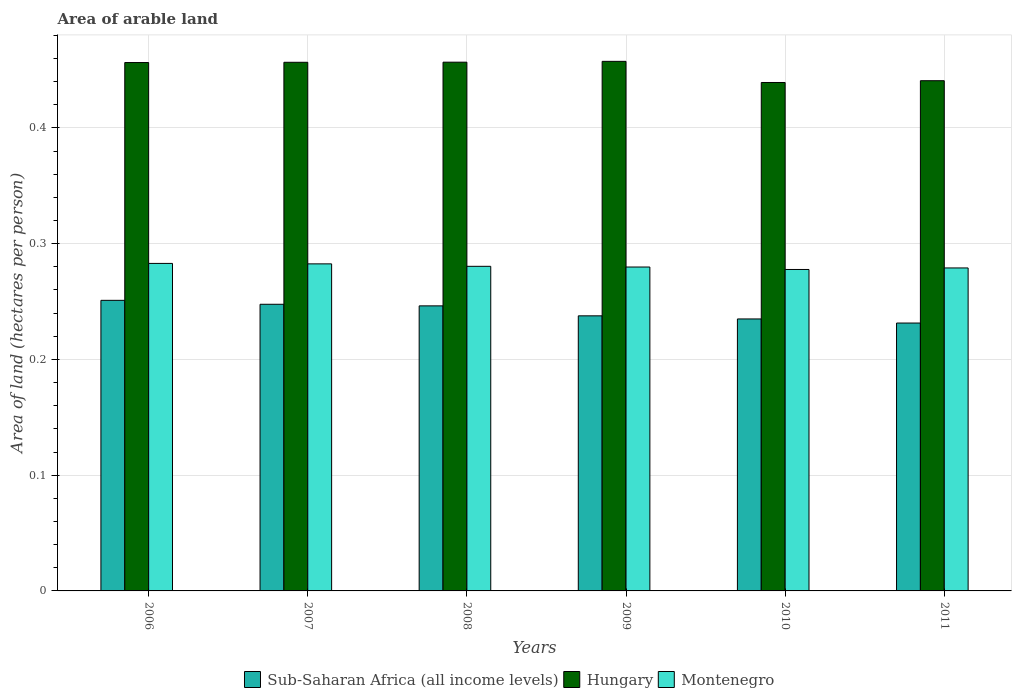Are the number of bars per tick equal to the number of legend labels?
Offer a very short reply. Yes. Are the number of bars on each tick of the X-axis equal?
Your answer should be very brief. Yes. What is the label of the 1st group of bars from the left?
Your answer should be very brief. 2006. In how many cases, is the number of bars for a given year not equal to the number of legend labels?
Provide a short and direct response. 0. What is the total arable land in Montenegro in 2011?
Give a very brief answer. 0.28. Across all years, what is the maximum total arable land in Montenegro?
Make the answer very short. 0.28. Across all years, what is the minimum total arable land in Montenegro?
Your answer should be very brief. 0.28. In which year was the total arable land in Sub-Saharan Africa (all income levels) minimum?
Give a very brief answer. 2011. What is the total total arable land in Montenegro in the graph?
Ensure brevity in your answer.  1.68. What is the difference between the total arable land in Montenegro in 2009 and that in 2010?
Provide a succinct answer. 0. What is the difference between the total arable land in Sub-Saharan Africa (all income levels) in 2007 and the total arable land in Hungary in 2010?
Make the answer very short. -0.19. What is the average total arable land in Sub-Saharan Africa (all income levels) per year?
Provide a short and direct response. 0.24. In the year 2010, what is the difference between the total arable land in Sub-Saharan Africa (all income levels) and total arable land in Montenegro?
Ensure brevity in your answer.  -0.04. In how many years, is the total arable land in Sub-Saharan Africa (all income levels) greater than 0.24000000000000002 hectares per person?
Ensure brevity in your answer.  3. What is the ratio of the total arable land in Sub-Saharan Africa (all income levels) in 2007 to that in 2011?
Keep it short and to the point. 1.07. Is the total arable land in Sub-Saharan Africa (all income levels) in 2009 less than that in 2010?
Give a very brief answer. No. What is the difference between the highest and the second highest total arable land in Sub-Saharan Africa (all income levels)?
Provide a short and direct response. 0. What is the difference between the highest and the lowest total arable land in Sub-Saharan Africa (all income levels)?
Your answer should be very brief. 0.02. What does the 2nd bar from the left in 2009 represents?
Make the answer very short. Hungary. What does the 3rd bar from the right in 2008 represents?
Your answer should be compact. Sub-Saharan Africa (all income levels). Are all the bars in the graph horizontal?
Provide a succinct answer. No. How many years are there in the graph?
Offer a terse response. 6. Are the values on the major ticks of Y-axis written in scientific E-notation?
Provide a succinct answer. No. Where does the legend appear in the graph?
Provide a succinct answer. Bottom center. How many legend labels are there?
Provide a succinct answer. 3. What is the title of the graph?
Your answer should be very brief. Area of arable land. Does "Liberia" appear as one of the legend labels in the graph?
Offer a very short reply. No. What is the label or title of the X-axis?
Make the answer very short. Years. What is the label or title of the Y-axis?
Ensure brevity in your answer.  Area of land (hectares per person). What is the Area of land (hectares per person) in Sub-Saharan Africa (all income levels) in 2006?
Offer a terse response. 0.25. What is the Area of land (hectares per person) of Hungary in 2006?
Offer a terse response. 0.46. What is the Area of land (hectares per person) in Montenegro in 2006?
Your answer should be compact. 0.28. What is the Area of land (hectares per person) of Sub-Saharan Africa (all income levels) in 2007?
Offer a very short reply. 0.25. What is the Area of land (hectares per person) in Hungary in 2007?
Your answer should be very brief. 0.46. What is the Area of land (hectares per person) in Montenegro in 2007?
Offer a very short reply. 0.28. What is the Area of land (hectares per person) of Sub-Saharan Africa (all income levels) in 2008?
Give a very brief answer. 0.25. What is the Area of land (hectares per person) of Hungary in 2008?
Make the answer very short. 0.46. What is the Area of land (hectares per person) in Montenegro in 2008?
Offer a terse response. 0.28. What is the Area of land (hectares per person) of Sub-Saharan Africa (all income levels) in 2009?
Your response must be concise. 0.24. What is the Area of land (hectares per person) of Hungary in 2009?
Your response must be concise. 0.46. What is the Area of land (hectares per person) in Montenegro in 2009?
Give a very brief answer. 0.28. What is the Area of land (hectares per person) of Sub-Saharan Africa (all income levels) in 2010?
Ensure brevity in your answer.  0.23. What is the Area of land (hectares per person) of Hungary in 2010?
Give a very brief answer. 0.44. What is the Area of land (hectares per person) in Montenegro in 2010?
Provide a succinct answer. 0.28. What is the Area of land (hectares per person) in Sub-Saharan Africa (all income levels) in 2011?
Provide a succinct answer. 0.23. What is the Area of land (hectares per person) of Hungary in 2011?
Make the answer very short. 0.44. What is the Area of land (hectares per person) of Montenegro in 2011?
Provide a short and direct response. 0.28. Across all years, what is the maximum Area of land (hectares per person) of Sub-Saharan Africa (all income levels)?
Make the answer very short. 0.25. Across all years, what is the maximum Area of land (hectares per person) of Hungary?
Keep it short and to the point. 0.46. Across all years, what is the maximum Area of land (hectares per person) in Montenegro?
Ensure brevity in your answer.  0.28. Across all years, what is the minimum Area of land (hectares per person) of Sub-Saharan Africa (all income levels)?
Offer a very short reply. 0.23. Across all years, what is the minimum Area of land (hectares per person) in Hungary?
Give a very brief answer. 0.44. Across all years, what is the minimum Area of land (hectares per person) in Montenegro?
Make the answer very short. 0.28. What is the total Area of land (hectares per person) in Sub-Saharan Africa (all income levels) in the graph?
Make the answer very short. 1.45. What is the total Area of land (hectares per person) in Hungary in the graph?
Make the answer very short. 2.71. What is the total Area of land (hectares per person) in Montenegro in the graph?
Provide a short and direct response. 1.68. What is the difference between the Area of land (hectares per person) in Sub-Saharan Africa (all income levels) in 2006 and that in 2007?
Provide a short and direct response. 0. What is the difference between the Area of land (hectares per person) of Hungary in 2006 and that in 2007?
Your answer should be compact. -0. What is the difference between the Area of land (hectares per person) of Montenegro in 2006 and that in 2007?
Provide a succinct answer. 0. What is the difference between the Area of land (hectares per person) in Sub-Saharan Africa (all income levels) in 2006 and that in 2008?
Provide a short and direct response. 0. What is the difference between the Area of land (hectares per person) in Hungary in 2006 and that in 2008?
Offer a terse response. -0. What is the difference between the Area of land (hectares per person) of Montenegro in 2006 and that in 2008?
Provide a succinct answer. 0. What is the difference between the Area of land (hectares per person) of Sub-Saharan Africa (all income levels) in 2006 and that in 2009?
Make the answer very short. 0.01. What is the difference between the Area of land (hectares per person) in Hungary in 2006 and that in 2009?
Keep it short and to the point. -0. What is the difference between the Area of land (hectares per person) of Montenegro in 2006 and that in 2009?
Ensure brevity in your answer.  0. What is the difference between the Area of land (hectares per person) of Sub-Saharan Africa (all income levels) in 2006 and that in 2010?
Keep it short and to the point. 0.02. What is the difference between the Area of land (hectares per person) in Hungary in 2006 and that in 2010?
Ensure brevity in your answer.  0.02. What is the difference between the Area of land (hectares per person) in Montenegro in 2006 and that in 2010?
Offer a very short reply. 0.01. What is the difference between the Area of land (hectares per person) in Sub-Saharan Africa (all income levels) in 2006 and that in 2011?
Make the answer very short. 0.02. What is the difference between the Area of land (hectares per person) of Hungary in 2006 and that in 2011?
Offer a very short reply. 0.02. What is the difference between the Area of land (hectares per person) in Montenegro in 2006 and that in 2011?
Offer a very short reply. 0. What is the difference between the Area of land (hectares per person) of Sub-Saharan Africa (all income levels) in 2007 and that in 2008?
Ensure brevity in your answer.  0. What is the difference between the Area of land (hectares per person) in Hungary in 2007 and that in 2008?
Offer a terse response. -0. What is the difference between the Area of land (hectares per person) of Montenegro in 2007 and that in 2008?
Your response must be concise. 0. What is the difference between the Area of land (hectares per person) in Hungary in 2007 and that in 2009?
Offer a terse response. -0. What is the difference between the Area of land (hectares per person) of Montenegro in 2007 and that in 2009?
Your answer should be very brief. 0. What is the difference between the Area of land (hectares per person) of Sub-Saharan Africa (all income levels) in 2007 and that in 2010?
Your answer should be compact. 0.01. What is the difference between the Area of land (hectares per person) in Hungary in 2007 and that in 2010?
Ensure brevity in your answer.  0.02. What is the difference between the Area of land (hectares per person) of Montenegro in 2007 and that in 2010?
Offer a terse response. 0. What is the difference between the Area of land (hectares per person) of Sub-Saharan Africa (all income levels) in 2007 and that in 2011?
Ensure brevity in your answer.  0.02. What is the difference between the Area of land (hectares per person) of Hungary in 2007 and that in 2011?
Offer a terse response. 0.02. What is the difference between the Area of land (hectares per person) in Montenegro in 2007 and that in 2011?
Give a very brief answer. 0. What is the difference between the Area of land (hectares per person) of Sub-Saharan Africa (all income levels) in 2008 and that in 2009?
Provide a short and direct response. 0.01. What is the difference between the Area of land (hectares per person) of Hungary in 2008 and that in 2009?
Provide a succinct answer. -0. What is the difference between the Area of land (hectares per person) in Montenegro in 2008 and that in 2009?
Ensure brevity in your answer.  0. What is the difference between the Area of land (hectares per person) of Sub-Saharan Africa (all income levels) in 2008 and that in 2010?
Make the answer very short. 0.01. What is the difference between the Area of land (hectares per person) of Hungary in 2008 and that in 2010?
Make the answer very short. 0.02. What is the difference between the Area of land (hectares per person) of Montenegro in 2008 and that in 2010?
Your answer should be compact. 0. What is the difference between the Area of land (hectares per person) of Sub-Saharan Africa (all income levels) in 2008 and that in 2011?
Your answer should be compact. 0.01. What is the difference between the Area of land (hectares per person) of Hungary in 2008 and that in 2011?
Ensure brevity in your answer.  0.02. What is the difference between the Area of land (hectares per person) in Montenegro in 2008 and that in 2011?
Provide a succinct answer. 0. What is the difference between the Area of land (hectares per person) of Sub-Saharan Africa (all income levels) in 2009 and that in 2010?
Give a very brief answer. 0. What is the difference between the Area of land (hectares per person) of Hungary in 2009 and that in 2010?
Your response must be concise. 0.02. What is the difference between the Area of land (hectares per person) in Montenegro in 2009 and that in 2010?
Offer a terse response. 0. What is the difference between the Area of land (hectares per person) in Sub-Saharan Africa (all income levels) in 2009 and that in 2011?
Make the answer very short. 0.01. What is the difference between the Area of land (hectares per person) of Hungary in 2009 and that in 2011?
Your response must be concise. 0.02. What is the difference between the Area of land (hectares per person) in Montenegro in 2009 and that in 2011?
Your answer should be very brief. 0. What is the difference between the Area of land (hectares per person) of Sub-Saharan Africa (all income levels) in 2010 and that in 2011?
Keep it short and to the point. 0. What is the difference between the Area of land (hectares per person) in Hungary in 2010 and that in 2011?
Your answer should be very brief. -0. What is the difference between the Area of land (hectares per person) in Montenegro in 2010 and that in 2011?
Give a very brief answer. -0. What is the difference between the Area of land (hectares per person) of Sub-Saharan Africa (all income levels) in 2006 and the Area of land (hectares per person) of Hungary in 2007?
Offer a terse response. -0.21. What is the difference between the Area of land (hectares per person) of Sub-Saharan Africa (all income levels) in 2006 and the Area of land (hectares per person) of Montenegro in 2007?
Ensure brevity in your answer.  -0.03. What is the difference between the Area of land (hectares per person) in Hungary in 2006 and the Area of land (hectares per person) in Montenegro in 2007?
Ensure brevity in your answer.  0.17. What is the difference between the Area of land (hectares per person) in Sub-Saharan Africa (all income levels) in 2006 and the Area of land (hectares per person) in Hungary in 2008?
Offer a very short reply. -0.21. What is the difference between the Area of land (hectares per person) of Sub-Saharan Africa (all income levels) in 2006 and the Area of land (hectares per person) of Montenegro in 2008?
Offer a terse response. -0.03. What is the difference between the Area of land (hectares per person) of Hungary in 2006 and the Area of land (hectares per person) of Montenegro in 2008?
Your response must be concise. 0.18. What is the difference between the Area of land (hectares per person) in Sub-Saharan Africa (all income levels) in 2006 and the Area of land (hectares per person) in Hungary in 2009?
Your response must be concise. -0.21. What is the difference between the Area of land (hectares per person) of Sub-Saharan Africa (all income levels) in 2006 and the Area of land (hectares per person) of Montenegro in 2009?
Provide a short and direct response. -0.03. What is the difference between the Area of land (hectares per person) of Hungary in 2006 and the Area of land (hectares per person) of Montenegro in 2009?
Ensure brevity in your answer.  0.18. What is the difference between the Area of land (hectares per person) of Sub-Saharan Africa (all income levels) in 2006 and the Area of land (hectares per person) of Hungary in 2010?
Provide a short and direct response. -0.19. What is the difference between the Area of land (hectares per person) of Sub-Saharan Africa (all income levels) in 2006 and the Area of land (hectares per person) of Montenegro in 2010?
Your answer should be compact. -0.03. What is the difference between the Area of land (hectares per person) in Hungary in 2006 and the Area of land (hectares per person) in Montenegro in 2010?
Your answer should be very brief. 0.18. What is the difference between the Area of land (hectares per person) in Sub-Saharan Africa (all income levels) in 2006 and the Area of land (hectares per person) in Hungary in 2011?
Your answer should be compact. -0.19. What is the difference between the Area of land (hectares per person) in Sub-Saharan Africa (all income levels) in 2006 and the Area of land (hectares per person) in Montenegro in 2011?
Your answer should be very brief. -0.03. What is the difference between the Area of land (hectares per person) of Hungary in 2006 and the Area of land (hectares per person) of Montenegro in 2011?
Your answer should be very brief. 0.18. What is the difference between the Area of land (hectares per person) in Sub-Saharan Africa (all income levels) in 2007 and the Area of land (hectares per person) in Hungary in 2008?
Ensure brevity in your answer.  -0.21. What is the difference between the Area of land (hectares per person) in Sub-Saharan Africa (all income levels) in 2007 and the Area of land (hectares per person) in Montenegro in 2008?
Provide a short and direct response. -0.03. What is the difference between the Area of land (hectares per person) of Hungary in 2007 and the Area of land (hectares per person) of Montenegro in 2008?
Offer a terse response. 0.18. What is the difference between the Area of land (hectares per person) in Sub-Saharan Africa (all income levels) in 2007 and the Area of land (hectares per person) in Hungary in 2009?
Offer a very short reply. -0.21. What is the difference between the Area of land (hectares per person) of Sub-Saharan Africa (all income levels) in 2007 and the Area of land (hectares per person) of Montenegro in 2009?
Your answer should be compact. -0.03. What is the difference between the Area of land (hectares per person) of Hungary in 2007 and the Area of land (hectares per person) of Montenegro in 2009?
Provide a short and direct response. 0.18. What is the difference between the Area of land (hectares per person) of Sub-Saharan Africa (all income levels) in 2007 and the Area of land (hectares per person) of Hungary in 2010?
Provide a short and direct response. -0.19. What is the difference between the Area of land (hectares per person) of Sub-Saharan Africa (all income levels) in 2007 and the Area of land (hectares per person) of Montenegro in 2010?
Your answer should be very brief. -0.03. What is the difference between the Area of land (hectares per person) in Hungary in 2007 and the Area of land (hectares per person) in Montenegro in 2010?
Provide a succinct answer. 0.18. What is the difference between the Area of land (hectares per person) in Sub-Saharan Africa (all income levels) in 2007 and the Area of land (hectares per person) in Hungary in 2011?
Provide a succinct answer. -0.19. What is the difference between the Area of land (hectares per person) of Sub-Saharan Africa (all income levels) in 2007 and the Area of land (hectares per person) of Montenegro in 2011?
Ensure brevity in your answer.  -0.03. What is the difference between the Area of land (hectares per person) in Hungary in 2007 and the Area of land (hectares per person) in Montenegro in 2011?
Offer a terse response. 0.18. What is the difference between the Area of land (hectares per person) of Sub-Saharan Africa (all income levels) in 2008 and the Area of land (hectares per person) of Hungary in 2009?
Keep it short and to the point. -0.21. What is the difference between the Area of land (hectares per person) of Sub-Saharan Africa (all income levels) in 2008 and the Area of land (hectares per person) of Montenegro in 2009?
Your answer should be very brief. -0.03. What is the difference between the Area of land (hectares per person) of Hungary in 2008 and the Area of land (hectares per person) of Montenegro in 2009?
Your response must be concise. 0.18. What is the difference between the Area of land (hectares per person) in Sub-Saharan Africa (all income levels) in 2008 and the Area of land (hectares per person) in Hungary in 2010?
Provide a succinct answer. -0.19. What is the difference between the Area of land (hectares per person) of Sub-Saharan Africa (all income levels) in 2008 and the Area of land (hectares per person) of Montenegro in 2010?
Offer a very short reply. -0.03. What is the difference between the Area of land (hectares per person) of Hungary in 2008 and the Area of land (hectares per person) of Montenegro in 2010?
Give a very brief answer. 0.18. What is the difference between the Area of land (hectares per person) of Sub-Saharan Africa (all income levels) in 2008 and the Area of land (hectares per person) of Hungary in 2011?
Make the answer very short. -0.19. What is the difference between the Area of land (hectares per person) of Sub-Saharan Africa (all income levels) in 2008 and the Area of land (hectares per person) of Montenegro in 2011?
Your answer should be very brief. -0.03. What is the difference between the Area of land (hectares per person) of Hungary in 2008 and the Area of land (hectares per person) of Montenegro in 2011?
Provide a succinct answer. 0.18. What is the difference between the Area of land (hectares per person) in Sub-Saharan Africa (all income levels) in 2009 and the Area of land (hectares per person) in Hungary in 2010?
Ensure brevity in your answer.  -0.2. What is the difference between the Area of land (hectares per person) of Sub-Saharan Africa (all income levels) in 2009 and the Area of land (hectares per person) of Montenegro in 2010?
Ensure brevity in your answer.  -0.04. What is the difference between the Area of land (hectares per person) of Hungary in 2009 and the Area of land (hectares per person) of Montenegro in 2010?
Ensure brevity in your answer.  0.18. What is the difference between the Area of land (hectares per person) in Sub-Saharan Africa (all income levels) in 2009 and the Area of land (hectares per person) in Hungary in 2011?
Your response must be concise. -0.2. What is the difference between the Area of land (hectares per person) in Sub-Saharan Africa (all income levels) in 2009 and the Area of land (hectares per person) in Montenegro in 2011?
Ensure brevity in your answer.  -0.04. What is the difference between the Area of land (hectares per person) in Hungary in 2009 and the Area of land (hectares per person) in Montenegro in 2011?
Your response must be concise. 0.18. What is the difference between the Area of land (hectares per person) in Sub-Saharan Africa (all income levels) in 2010 and the Area of land (hectares per person) in Hungary in 2011?
Provide a short and direct response. -0.21. What is the difference between the Area of land (hectares per person) in Sub-Saharan Africa (all income levels) in 2010 and the Area of land (hectares per person) in Montenegro in 2011?
Your response must be concise. -0.04. What is the difference between the Area of land (hectares per person) of Hungary in 2010 and the Area of land (hectares per person) of Montenegro in 2011?
Provide a succinct answer. 0.16. What is the average Area of land (hectares per person) of Sub-Saharan Africa (all income levels) per year?
Offer a very short reply. 0.24. What is the average Area of land (hectares per person) of Hungary per year?
Provide a succinct answer. 0.45. What is the average Area of land (hectares per person) in Montenegro per year?
Ensure brevity in your answer.  0.28. In the year 2006, what is the difference between the Area of land (hectares per person) in Sub-Saharan Africa (all income levels) and Area of land (hectares per person) in Hungary?
Your answer should be very brief. -0.21. In the year 2006, what is the difference between the Area of land (hectares per person) of Sub-Saharan Africa (all income levels) and Area of land (hectares per person) of Montenegro?
Offer a very short reply. -0.03. In the year 2006, what is the difference between the Area of land (hectares per person) of Hungary and Area of land (hectares per person) of Montenegro?
Give a very brief answer. 0.17. In the year 2007, what is the difference between the Area of land (hectares per person) of Sub-Saharan Africa (all income levels) and Area of land (hectares per person) of Hungary?
Your answer should be very brief. -0.21. In the year 2007, what is the difference between the Area of land (hectares per person) of Sub-Saharan Africa (all income levels) and Area of land (hectares per person) of Montenegro?
Keep it short and to the point. -0.03. In the year 2007, what is the difference between the Area of land (hectares per person) in Hungary and Area of land (hectares per person) in Montenegro?
Ensure brevity in your answer.  0.17. In the year 2008, what is the difference between the Area of land (hectares per person) of Sub-Saharan Africa (all income levels) and Area of land (hectares per person) of Hungary?
Provide a succinct answer. -0.21. In the year 2008, what is the difference between the Area of land (hectares per person) of Sub-Saharan Africa (all income levels) and Area of land (hectares per person) of Montenegro?
Provide a short and direct response. -0.03. In the year 2008, what is the difference between the Area of land (hectares per person) of Hungary and Area of land (hectares per person) of Montenegro?
Your response must be concise. 0.18. In the year 2009, what is the difference between the Area of land (hectares per person) in Sub-Saharan Africa (all income levels) and Area of land (hectares per person) in Hungary?
Provide a short and direct response. -0.22. In the year 2009, what is the difference between the Area of land (hectares per person) of Sub-Saharan Africa (all income levels) and Area of land (hectares per person) of Montenegro?
Ensure brevity in your answer.  -0.04. In the year 2009, what is the difference between the Area of land (hectares per person) of Hungary and Area of land (hectares per person) of Montenegro?
Your response must be concise. 0.18. In the year 2010, what is the difference between the Area of land (hectares per person) of Sub-Saharan Africa (all income levels) and Area of land (hectares per person) of Hungary?
Your answer should be very brief. -0.2. In the year 2010, what is the difference between the Area of land (hectares per person) in Sub-Saharan Africa (all income levels) and Area of land (hectares per person) in Montenegro?
Offer a very short reply. -0.04. In the year 2010, what is the difference between the Area of land (hectares per person) of Hungary and Area of land (hectares per person) of Montenegro?
Your answer should be compact. 0.16. In the year 2011, what is the difference between the Area of land (hectares per person) in Sub-Saharan Africa (all income levels) and Area of land (hectares per person) in Hungary?
Provide a short and direct response. -0.21. In the year 2011, what is the difference between the Area of land (hectares per person) in Sub-Saharan Africa (all income levels) and Area of land (hectares per person) in Montenegro?
Provide a succinct answer. -0.05. In the year 2011, what is the difference between the Area of land (hectares per person) of Hungary and Area of land (hectares per person) of Montenegro?
Provide a succinct answer. 0.16. What is the ratio of the Area of land (hectares per person) of Sub-Saharan Africa (all income levels) in 2006 to that in 2007?
Offer a very short reply. 1.01. What is the ratio of the Area of land (hectares per person) of Hungary in 2006 to that in 2007?
Provide a succinct answer. 1. What is the ratio of the Area of land (hectares per person) in Sub-Saharan Africa (all income levels) in 2006 to that in 2008?
Offer a very short reply. 1.02. What is the ratio of the Area of land (hectares per person) of Hungary in 2006 to that in 2008?
Your answer should be compact. 1. What is the ratio of the Area of land (hectares per person) of Sub-Saharan Africa (all income levels) in 2006 to that in 2009?
Provide a short and direct response. 1.06. What is the ratio of the Area of land (hectares per person) of Hungary in 2006 to that in 2009?
Your answer should be compact. 1. What is the ratio of the Area of land (hectares per person) of Montenegro in 2006 to that in 2009?
Give a very brief answer. 1.01. What is the ratio of the Area of land (hectares per person) in Sub-Saharan Africa (all income levels) in 2006 to that in 2010?
Your answer should be very brief. 1.07. What is the ratio of the Area of land (hectares per person) of Hungary in 2006 to that in 2010?
Offer a very short reply. 1.04. What is the ratio of the Area of land (hectares per person) in Montenegro in 2006 to that in 2010?
Offer a very short reply. 1.02. What is the ratio of the Area of land (hectares per person) in Sub-Saharan Africa (all income levels) in 2006 to that in 2011?
Make the answer very short. 1.08. What is the ratio of the Area of land (hectares per person) in Hungary in 2006 to that in 2011?
Keep it short and to the point. 1.04. What is the ratio of the Area of land (hectares per person) in Montenegro in 2006 to that in 2011?
Offer a terse response. 1.01. What is the ratio of the Area of land (hectares per person) in Sub-Saharan Africa (all income levels) in 2007 to that in 2008?
Provide a succinct answer. 1.01. What is the ratio of the Area of land (hectares per person) of Hungary in 2007 to that in 2008?
Give a very brief answer. 1. What is the ratio of the Area of land (hectares per person) in Montenegro in 2007 to that in 2008?
Your answer should be very brief. 1.01. What is the ratio of the Area of land (hectares per person) in Sub-Saharan Africa (all income levels) in 2007 to that in 2009?
Offer a very short reply. 1.04. What is the ratio of the Area of land (hectares per person) in Montenegro in 2007 to that in 2009?
Offer a terse response. 1.01. What is the ratio of the Area of land (hectares per person) in Sub-Saharan Africa (all income levels) in 2007 to that in 2010?
Offer a terse response. 1.05. What is the ratio of the Area of land (hectares per person) in Hungary in 2007 to that in 2010?
Offer a terse response. 1.04. What is the ratio of the Area of land (hectares per person) of Montenegro in 2007 to that in 2010?
Your answer should be very brief. 1.02. What is the ratio of the Area of land (hectares per person) in Sub-Saharan Africa (all income levels) in 2007 to that in 2011?
Provide a short and direct response. 1.07. What is the ratio of the Area of land (hectares per person) in Hungary in 2007 to that in 2011?
Your answer should be very brief. 1.04. What is the ratio of the Area of land (hectares per person) of Montenegro in 2007 to that in 2011?
Your answer should be compact. 1.01. What is the ratio of the Area of land (hectares per person) of Sub-Saharan Africa (all income levels) in 2008 to that in 2009?
Your answer should be compact. 1.04. What is the ratio of the Area of land (hectares per person) in Hungary in 2008 to that in 2009?
Keep it short and to the point. 1. What is the ratio of the Area of land (hectares per person) in Sub-Saharan Africa (all income levels) in 2008 to that in 2010?
Keep it short and to the point. 1.05. What is the ratio of the Area of land (hectares per person) of Montenegro in 2008 to that in 2010?
Your response must be concise. 1.01. What is the ratio of the Area of land (hectares per person) in Sub-Saharan Africa (all income levels) in 2008 to that in 2011?
Ensure brevity in your answer.  1.06. What is the ratio of the Area of land (hectares per person) in Hungary in 2008 to that in 2011?
Offer a terse response. 1.04. What is the ratio of the Area of land (hectares per person) in Sub-Saharan Africa (all income levels) in 2009 to that in 2010?
Make the answer very short. 1.01. What is the ratio of the Area of land (hectares per person) in Hungary in 2009 to that in 2010?
Make the answer very short. 1.04. What is the ratio of the Area of land (hectares per person) of Montenegro in 2009 to that in 2010?
Provide a short and direct response. 1.01. What is the ratio of the Area of land (hectares per person) in Sub-Saharan Africa (all income levels) in 2009 to that in 2011?
Keep it short and to the point. 1.03. What is the ratio of the Area of land (hectares per person) of Hungary in 2009 to that in 2011?
Your answer should be very brief. 1.04. What is the ratio of the Area of land (hectares per person) of Sub-Saharan Africa (all income levels) in 2010 to that in 2011?
Offer a very short reply. 1.02. What is the ratio of the Area of land (hectares per person) of Montenegro in 2010 to that in 2011?
Keep it short and to the point. 1. What is the difference between the highest and the second highest Area of land (hectares per person) of Sub-Saharan Africa (all income levels)?
Your answer should be very brief. 0. What is the difference between the highest and the second highest Area of land (hectares per person) of Hungary?
Provide a short and direct response. 0. What is the difference between the highest and the second highest Area of land (hectares per person) of Montenegro?
Ensure brevity in your answer.  0. What is the difference between the highest and the lowest Area of land (hectares per person) in Sub-Saharan Africa (all income levels)?
Your response must be concise. 0.02. What is the difference between the highest and the lowest Area of land (hectares per person) in Hungary?
Give a very brief answer. 0.02. What is the difference between the highest and the lowest Area of land (hectares per person) in Montenegro?
Keep it short and to the point. 0.01. 